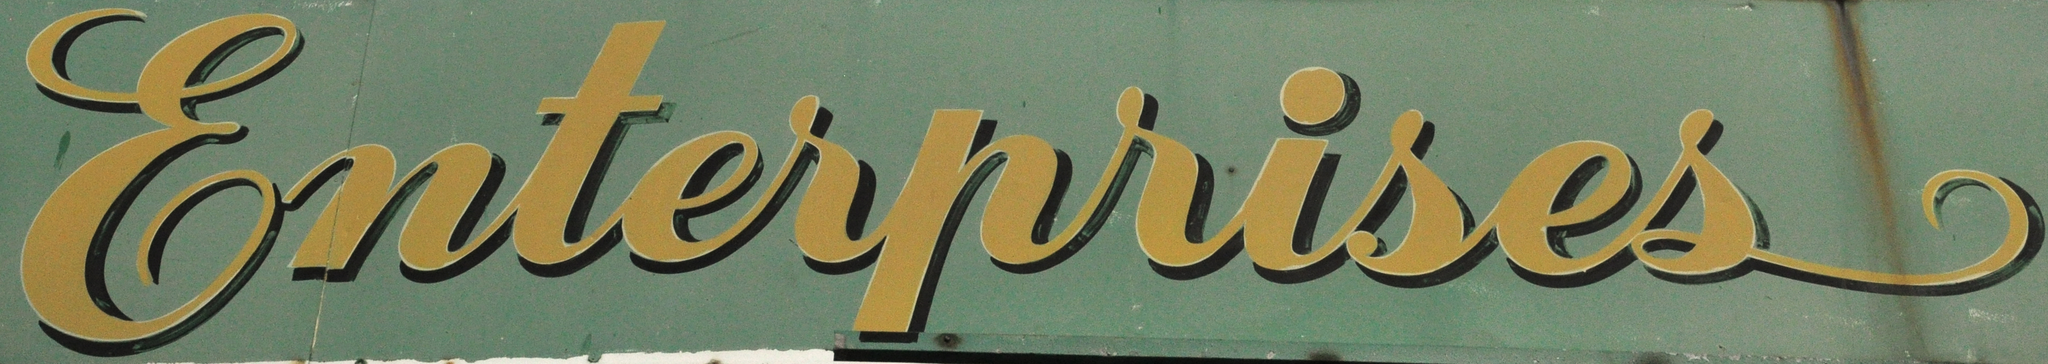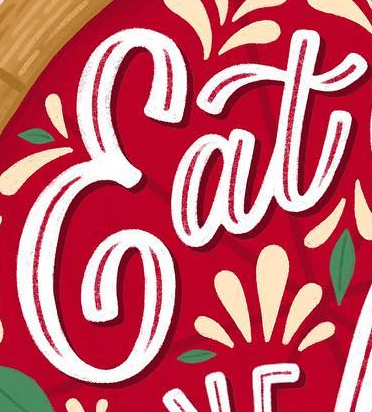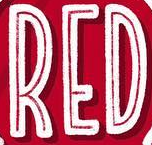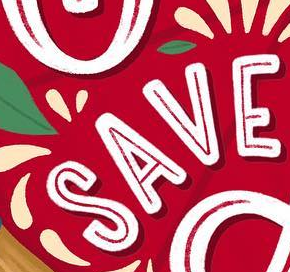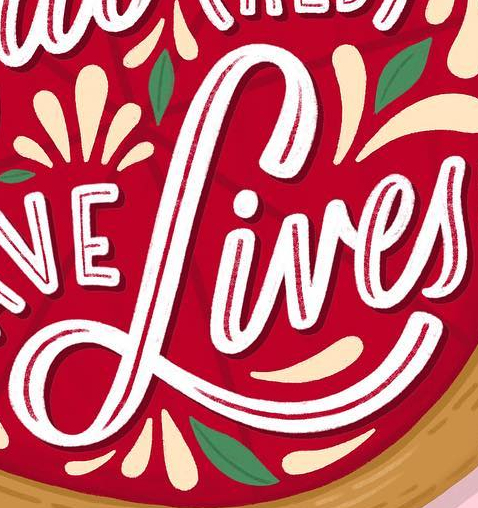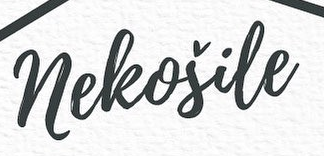Read the text content from these images in order, separated by a semicolon. Enterprises; Eat; RED; SAVE; Lives; neleošile 